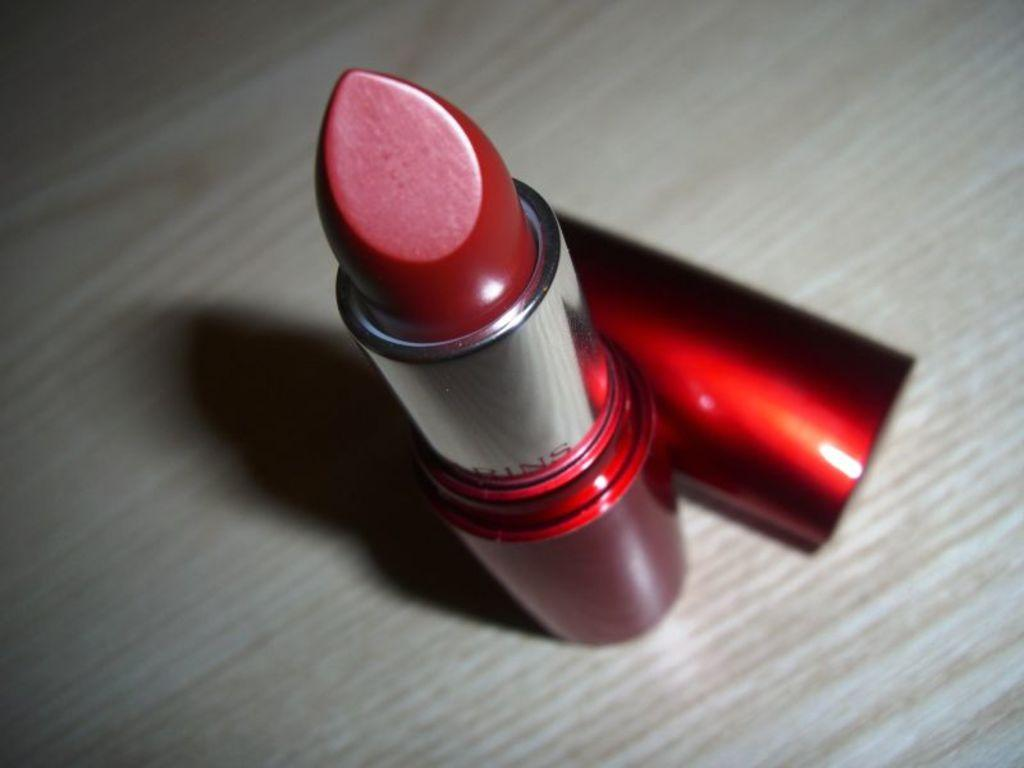What type of cosmetic product is visible in the image? There is red color lipstick in the image. What else can be seen on the table in the image? There is a cap on the table in the image. How many parts of the ant can be seen in the image? There is no ant present in the image, so it is not possible to determine the number of parts visible. 